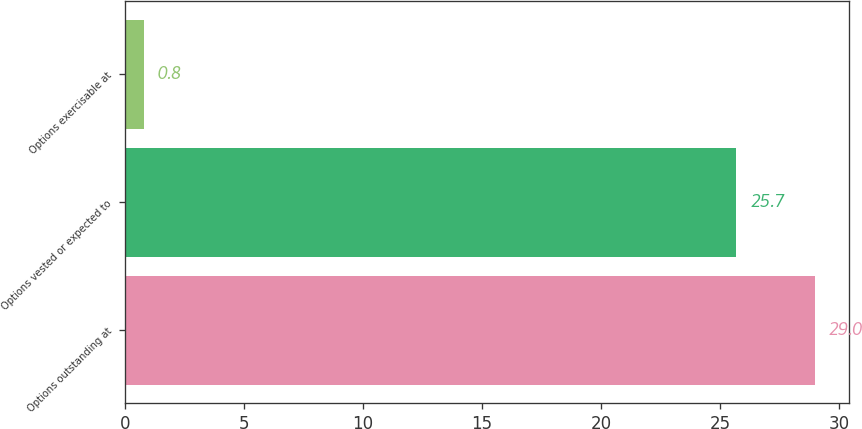Convert chart. <chart><loc_0><loc_0><loc_500><loc_500><bar_chart><fcel>Options outstanding at<fcel>Options vested or expected to<fcel>Options exercisable at<nl><fcel>29<fcel>25.7<fcel>0.8<nl></chart> 